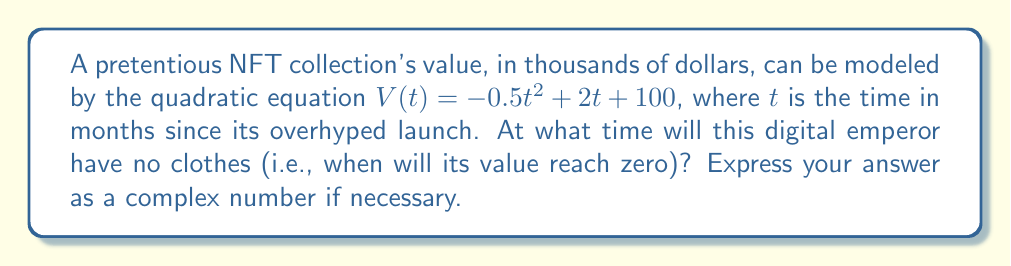Could you help me with this problem? To find when the value reaches zero, we need to solve the equation:

$$-0.5t^2 + 2t + 100 = 0$$

This is a quadratic equation in the form $at^2 + bt + c = 0$, where:
$a = -0.5$, $b = 2$, and $c = 100$

We can solve this using the quadratic formula: $t = \frac{-b \pm \sqrt{b^2 - 4ac}}{2a}$

Substituting our values:

$$t = \frac{-2 \pm \sqrt{2^2 - 4(-0.5)(100)}}{2(-0.5)}$$

$$t = \frac{-2 \pm \sqrt{4 + 200}}{-1}$$

$$t = \frac{-2 \pm \sqrt{204}}{-1}$$

$$t = \frac{-2 \pm 14.28}{-1}$$

This gives us two solutions:

$$t_1 = \frac{-2 + 14.28}{-1} = -12.28$$

$$t_2 = \frac{-2 - 14.28}{-1} = 16.28$$

The negative solution (-12.28) doesn't make sense in the context of time since launch. Therefore, the value of the NFT collection will reach zero after approximately 16.28 months.
Answer: $16.28$ months 